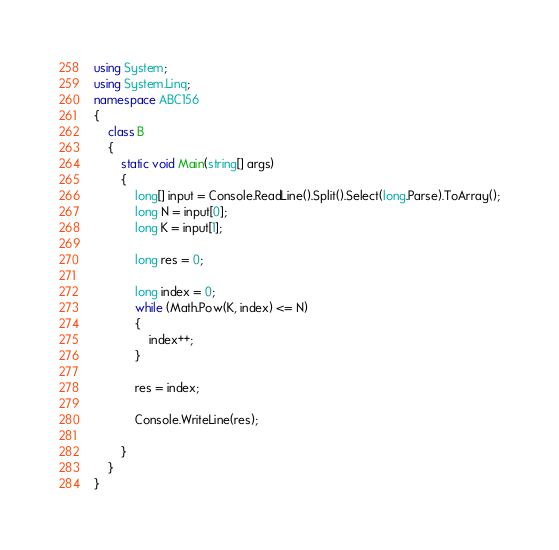<code> <loc_0><loc_0><loc_500><loc_500><_C#_>using System;
using System.Linq;
namespace ABC156
{
    class B
    {
        static void Main(string[] args)
        {
            long[] input = Console.ReadLine().Split().Select(long.Parse).ToArray();
            long N = input[0];
            long K = input[1];

            long res = 0;

            long index = 0;
            while (Math.Pow(K, index) <= N)
            {
                index++;
            }

            res = index;

            Console.WriteLine(res);

        }
    }
}
</code> 